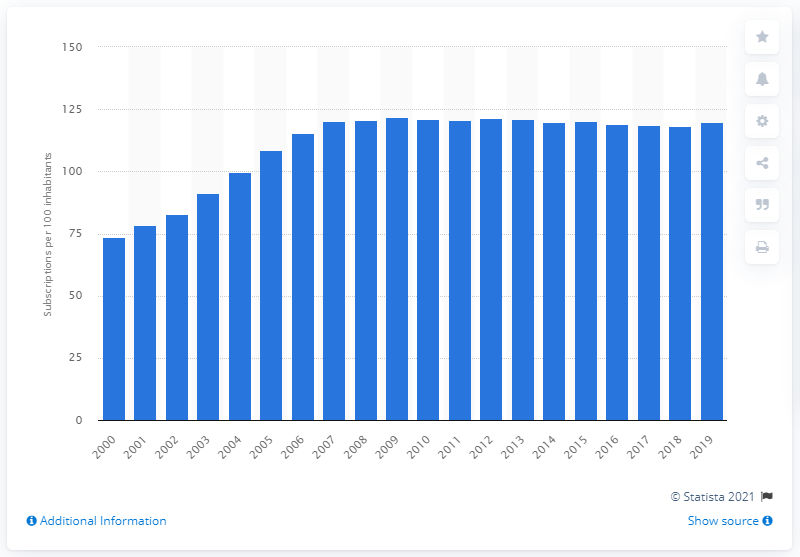Draw attention to some important aspects in this diagram. In the United Kingdom between 2000 and 2019, the average number of mobile cellular subscriptions per 100 inhabitants was 119.9. 